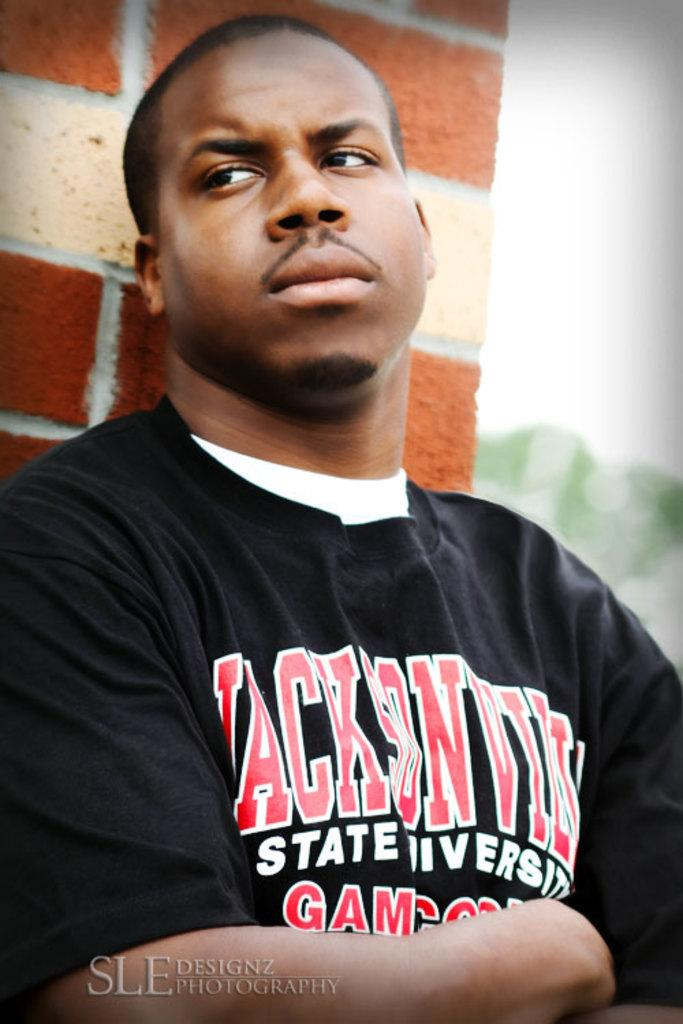Provide a one-sentence caption for the provided image. A man wearing a shirt that says Jackson State university stands against a brick wall. 